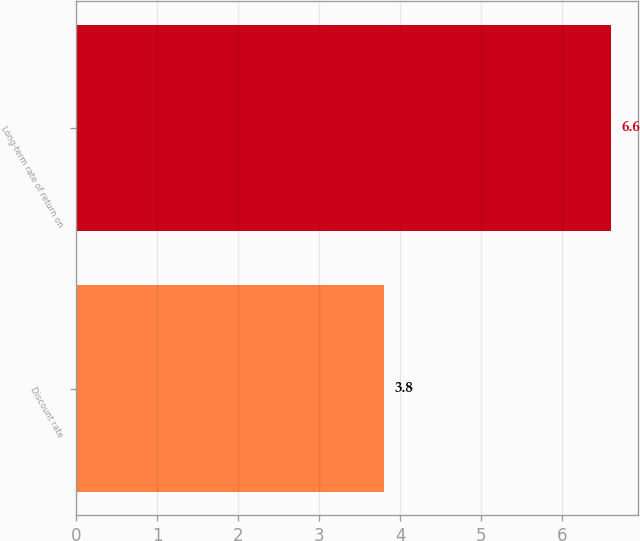Convert chart to OTSL. <chart><loc_0><loc_0><loc_500><loc_500><bar_chart><fcel>Discount rate<fcel>Long-term rate of return on<nl><fcel>3.8<fcel>6.6<nl></chart> 